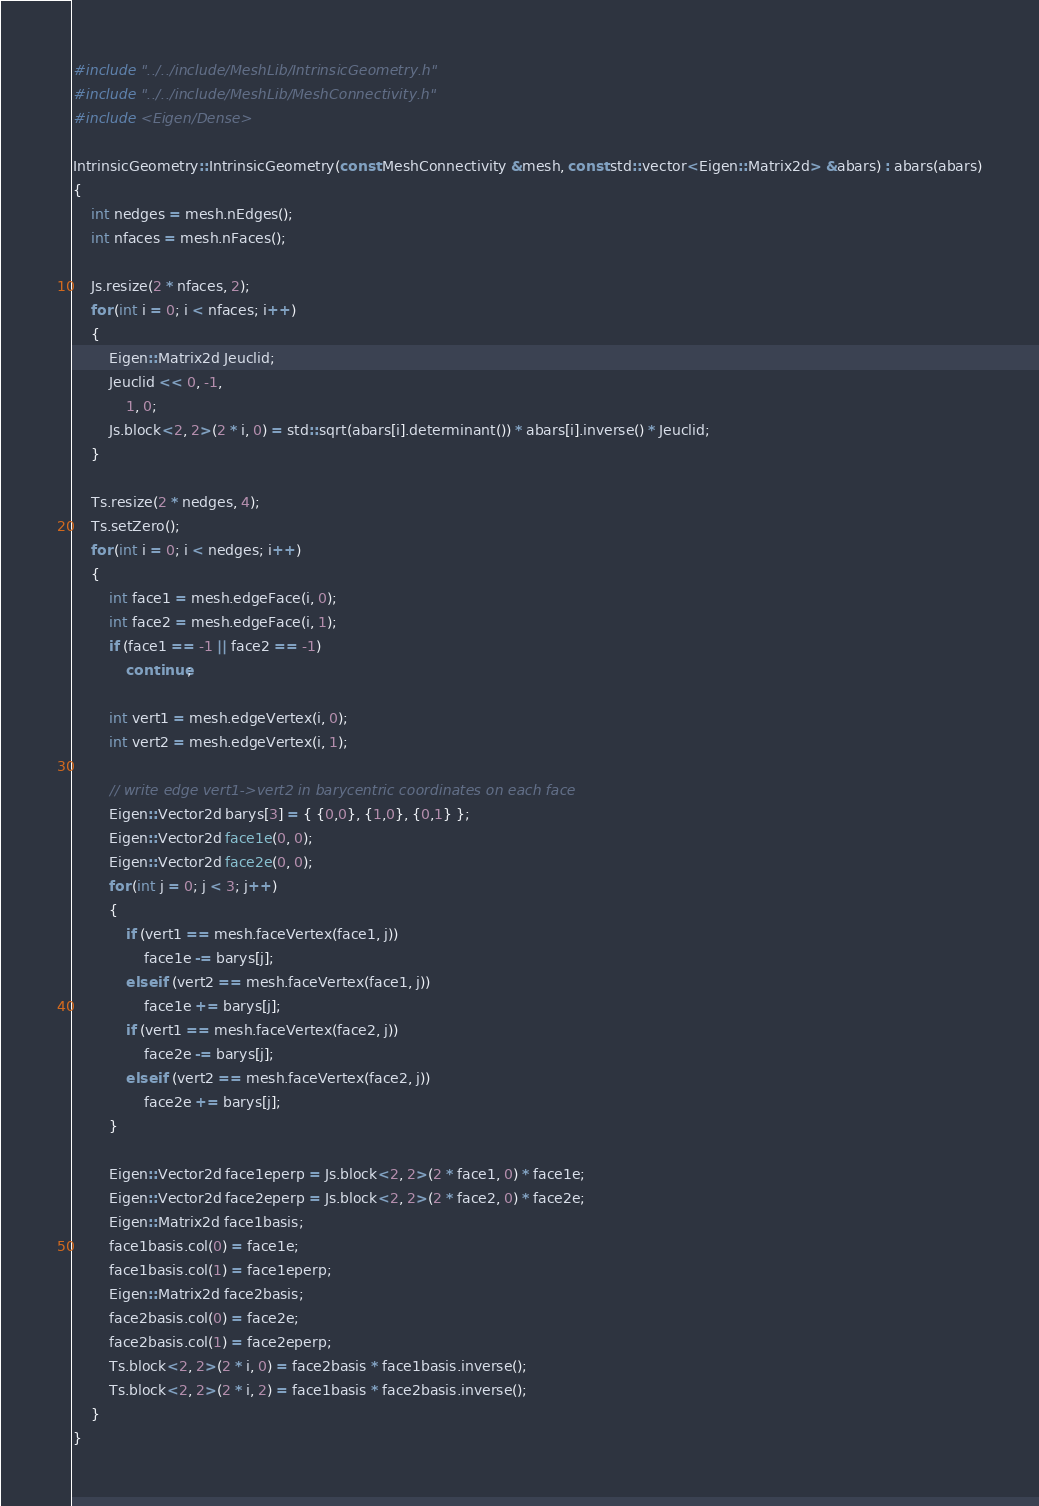Convert code to text. <code><loc_0><loc_0><loc_500><loc_500><_C++_>#include "../../include/MeshLib/IntrinsicGeometry.h"
#include "../../include/MeshLib/MeshConnectivity.h"
#include <Eigen/Dense>

IntrinsicGeometry::IntrinsicGeometry(const MeshConnectivity &mesh, const std::vector<Eigen::Matrix2d> &abars) : abars(abars)
{
    int nedges = mesh.nEdges();
    int nfaces = mesh.nFaces();

    Js.resize(2 * nfaces, 2);
    for (int i = 0; i < nfaces; i++)
    {
        Eigen::Matrix2d Jeuclid;
        Jeuclid << 0, -1,
            1, 0;
        Js.block<2, 2>(2 * i, 0) = std::sqrt(abars[i].determinant()) * abars[i].inverse() * Jeuclid;
    }

    Ts.resize(2 * nedges, 4);
    Ts.setZero();
    for (int i = 0; i < nedges; i++)
    {
        int face1 = mesh.edgeFace(i, 0);
        int face2 = mesh.edgeFace(i, 1);
        if (face1 == -1 || face2 == -1)
            continue;

        int vert1 = mesh.edgeVertex(i, 0);
        int vert2 = mesh.edgeVertex(i, 1);

        // write edge vert1->vert2 in barycentric coordinates on each face
        Eigen::Vector2d barys[3] = { {0,0}, {1,0}, {0,1} };
        Eigen::Vector2d face1e(0, 0);
        Eigen::Vector2d face2e(0, 0);
        for (int j = 0; j < 3; j++)
        {
            if (vert1 == mesh.faceVertex(face1, j))
                face1e -= barys[j];
            else if (vert2 == mesh.faceVertex(face1, j))
                face1e += barys[j];
            if (vert1 == mesh.faceVertex(face2, j))
                face2e -= barys[j];
            else if (vert2 == mesh.faceVertex(face2, j))
                face2e += barys[j];
        }

        Eigen::Vector2d face1eperp = Js.block<2, 2>(2 * face1, 0) * face1e;
        Eigen::Vector2d face2eperp = Js.block<2, 2>(2 * face2, 0) * face2e;
        Eigen::Matrix2d face1basis;
        face1basis.col(0) = face1e;
        face1basis.col(1) = face1eperp;
        Eigen::Matrix2d face2basis;
        face2basis.col(0) = face2e;
        face2basis.col(1) = face2eperp;
        Ts.block<2, 2>(2 * i, 0) = face2basis * face1basis.inverse();
        Ts.block<2, 2>(2 * i, 2) = face1basis * face2basis.inverse();
    }
}
</code> 